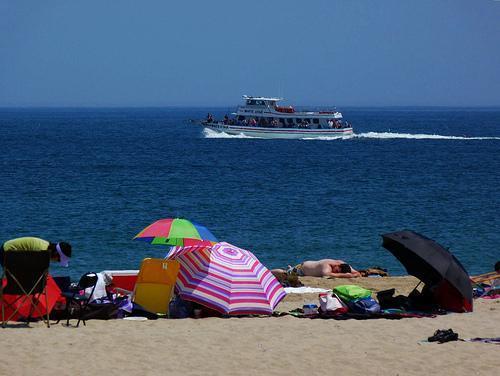How many umbrellas in picture?
Give a very brief answer. 3. How many black umbrellas are there?
Give a very brief answer. 1. 